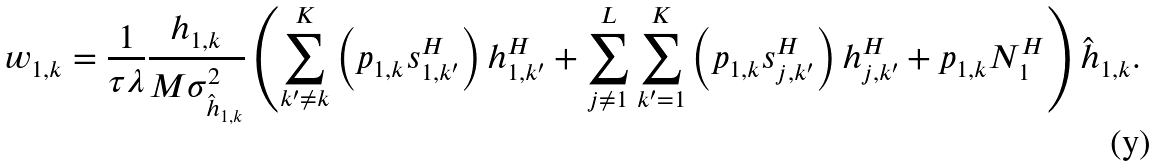Convert formula to latex. <formula><loc_0><loc_0><loc_500><loc_500>w _ { 1 , k } = \frac { 1 } { \tau \lambda } \frac { h _ { 1 , k } } { M \sigma _ { \hat { h } _ { 1 , k } } ^ { 2 } } \left ( \sum _ { k ^ { \prime } \neq k } ^ { K } \left ( p _ { 1 , k } s _ { 1 , k ^ { \prime } } ^ { H } \right ) h _ { 1 , k ^ { \prime } } ^ { H } + \sum _ { j \neq 1 } ^ { L } \sum _ { k ^ { \prime } = 1 } ^ { K } \left ( p _ { 1 , k } s _ { j , k ^ { \prime } } ^ { H } \right ) h _ { j , k ^ { \prime } } ^ { H } + p _ { 1 , k } N _ { 1 } ^ { H } \right ) \hat { h } _ { 1 , k } .</formula> 